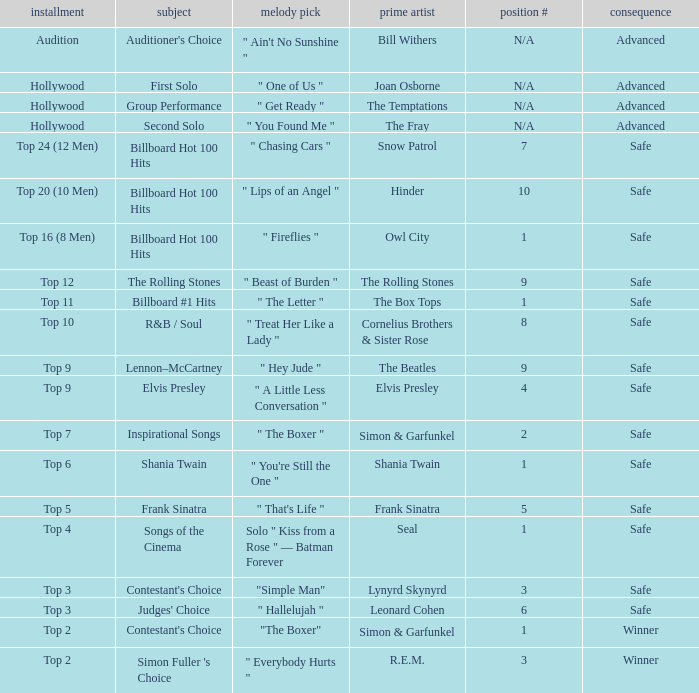Who is the original artist of the song choice " The Letter "? The Box Tops. 